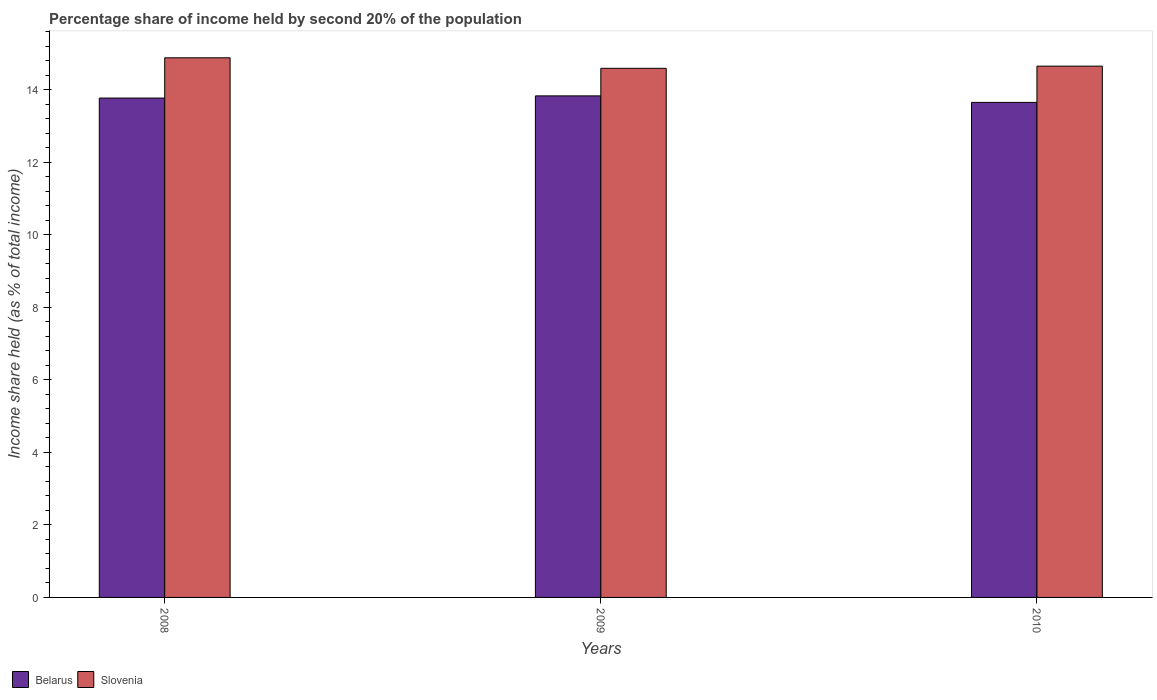How many different coloured bars are there?
Provide a short and direct response. 2. Are the number of bars per tick equal to the number of legend labels?
Ensure brevity in your answer.  Yes. In how many cases, is the number of bars for a given year not equal to the number of legend labels?
Offer a terse response. 0. What is the share of income held by second 20% of the population in Belarus in 2009?
Give a very brief answer. 13.83. Across all years, what is the maximum share of income held by second 20% of the population in Belarus?
Provide a succinct answer. 13.83. Across all years, what is the minimum share of income held by second 20% of the population in Slovenia?
Offer a very short reply. 14.59. In which year was the share of income held by second 20% of the population in Slovenia maximum?
Your answer should be very brief. 2008. In which year was the share of income held by second 20% of the population in Belarus minimum?
Give a very brief answer. 2010. What is the total share of income held by second 20% of the population in Belarus in the graph?
Offer a very short reply. 41.25. What is the difference between the share of income held by second 20% of the population in Slovenia in 2009 and that in 2010?
Your answer should be very brief. -0.06. What is the difference between the share of income held by second 20% of the population in Slovenia in 2008 and the share of income held by second 20% of the population in Belarus in 2010?
Give a very brief answer. 1.23. What is the average share of income held by second 20% of the population in Belarus per year?
Provide a succinct answer. 13.75. In the year 2010, what is the difference between the share of income held by second 20% of the population in Slovenia and share of income held by second 20% of the population in Belarus?
Provide a short and direct response. 1. In how many years, is the share of income held by second 20% of the population in Slovenia greater than 14.4 %?
Provide a short and direct response. 3. What is the ratio of the share of income held by second 20% of the population in Belarus in 2008 to that in 2009?
Offer a terse response. 1. Is the share of income held by second 20% of the population in Belarus in 2008 less than that in 2009?
Your response must be concise. Yes. Is the difference between the share of income held by second 20% of the population in Slovenia in 2009 and 2010 greater than the difference between the share of income held by second 20% of the population in Belarus in 2009 and 2010?
Ensure brevity in your answer.  No. What is the difference between the highest and the second highest share of income held by second 20% of the population in Slovenia?
Your answer should be very brief. 0.23. What is the difference between the highest and the lowest share of income held by second 20% of the population in Slovenia?
Your answer should be very brief. 0.29. In how many years, is the share of income held by second 20% of the population in Belarus greater than the average share of income held by second 20% of the population in Belarus taken over all years?
Make the answer very short. 2. What does the 2nd bar from the left in 2009 represents?
Provide a short and direct response. Slovenia. What does the 1st bar from the right in 2008 represents?
Ensure brevity in your answer.  Slovenia. Are all the bars in the graph horizontal?
Give a very brief answer. No. How many years are there in the graph?
Give a very brief answer. 3. How many legend labels are there?
Provide a short and direct response. 2. What is the title of the graph?
Give a very brief answer. Percentage share of income held by second 20% of the population. Does "Swaziland" appear as one of the legend labels in the graph?
Your response must be concise. No. What is the label or title of the X-axis?
Offer a terse response. Years. What is the label or title of the Y-axis?
Provide a short and direct response. Income share held (as % of total income). What is the Income share held (as % of total income) in Belarus in 2008?
Give a very brief answer. 13.77. What is the Income share held (as % of total income) of Slovenia in 2008?
Keep it short and to the point. 14.88. What is the Income share held (as % of total income) in Belarus in 2009?
Provide a short and direct response. 13.83. What is the Income share held (as % of total income) of Slovenia in 2009?
Offer a very short reply. 14.59. What is the Income share held (as % of total income) in Belarus in 2010?
Your answer should be compact. 13.65. What is the Income share held (as % of total income) of Slovenia in 2010?
Keep it short and to the point. 14.65. Across all years, what is the maximum Income share held (as % of total income) of Belarus?
Keep it short and to the point. 13.83. Across all years, what is the maximum Income share held (as % of total income) in Slovenia?
Your answer should be very brief. 14.88. Across all years, what is the minimum Income share held (as % of total income) of Belarus?
Ensure brevity in your answer.  13.65. Across all years, what is the minimum Income share held (as % of total income) of Slovenia?
Keep it short and to the point. 14.59. What is the total Income share held (as % of total income) in Belarus in the graph?
Offer a very short reply. 41.25. What is the total Income share held (as % of total income) of Slovenia in the graph?
Your answer should be very brief. 44.12. What is the difference between the Income share held (as % of total income) of Belarus in 2008 and that in 2009?
Your answer should be very brief. -0.06. What is the difference between the Income share held (as % of total income) of Slovenia in 2008 and that in 2009?
Provide a succinct answer. 0.29. What is the difference between the Income share held (as % of total income) in Belarus in 2008 and that in 2010?
Give a very brief answer. 0.12. What is the difference between the Income share held (as % of total income) in Slovenia in 2008 and that in 2010?
Provide a succinct answer. 0.23. What is the difference between the Income share held (as % of total income) in Belarus in 2009 and that in 2010?
Your response must be concise. 0.18. What is the difference between the Income share held (as % of total income) in Slovenia in 2009 and that in 2010?
Offer a very short reply. -0.06. What is the difference between the Income share held (as % of total income) in Belarus in 2008 and the Income share held (as % of total income) in Slovenia in 2009?
Offer a terse response. -0.82. What is the difference between the Income share held (as % of total income) in Belarus in 2008 and the Income share held (as % of total income) in Slovenia in 2010?
Your answer should be compact. -0.88. What is the difference between the Income share held (as % of total income) in Belarus in 2009 and the Income share held (as % of total income) in Slovenia in 2010?
Your answer should be very brief. -0.82. What is the average Income share held (as % of total income) of Belarus per year?
Provide a succinct answer. 13.75. What is the average Income share held (as % of total income) in Slovenia per year?
Provide a short and direct response. 14.71. In the year 2008, what is the difference between the Income share held (as % of total income) of Belarus and Income share held (as % of total income) of Slovenia?
Your response must be concise. -1.11. In the year 2009, what is the difference between the Income share held (as % of total income) in Belarus and Income share held (as % of total income) in Slovenia?
Offer a terse response. -0.76. In the year 2010, what is the difference between the Income share held (as % of total income) in Belarus and Income share held (as % of total income) in Slovenia?
Provide a succinct answer. -1. What is the ratio of the Income share held (as % of total income) in Slovenia in 2008 to that in 2009?
Your answer should be compact. 1.02. What is the ratio of the Income share held (as % of total income) in Belarus in 2008 to that in 2010?
Make the answer very short. 1.01. What is the ratio of the Income share held (as % of total income) in Slovenia in 2008 to that in 2010?
Make the answer very short. 1.02. What is the ratio of the Income share held (as % of total income) in Belarus in 2009 to that in 2010?
Offer a terse response. 1.01. What is the difference between the highest and the second highest Income share held (as % of total income) in Slovenia?
Offer a very short reply. 0.23. What is the difference between the highest and the lowest Income share held (as % of total income) of Belarus?
Make the answer very short. 0.18. What is the difference between the highest and the lowest Income share held (as % of total income) of Slovenia?
Ensure brevity in your answer.  0.29. 